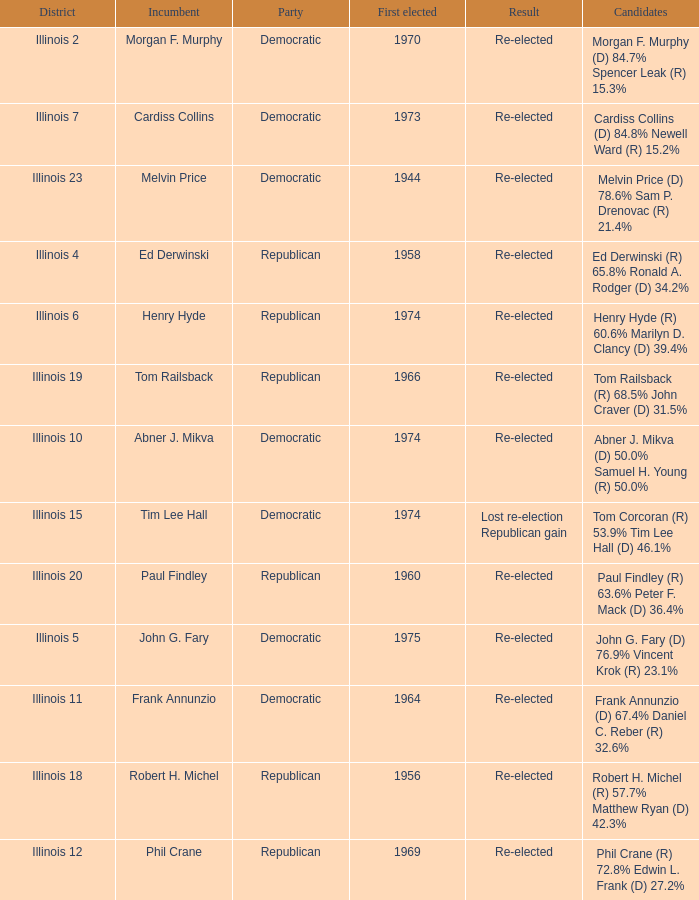Name the first elected for abner j. mikva 1974.0. 